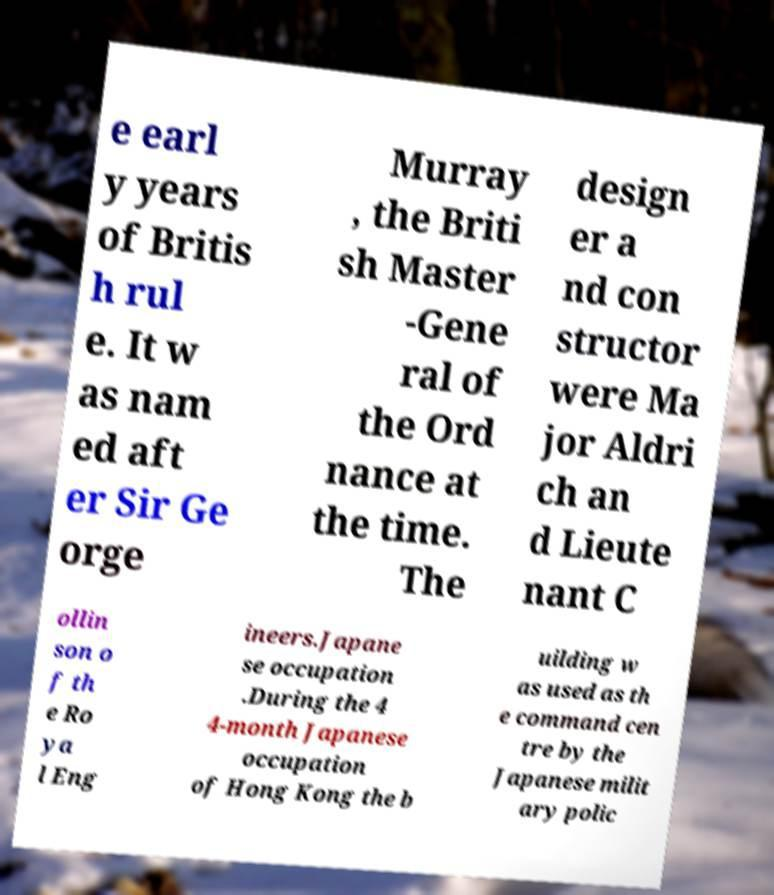What messages or text are displayed in this image? I need them in a readable, typed format. e earl y years of Britis h rul e. It w as nam ed aft er Sir Ge orge Murray , the Briti sh Master -Gene ral of the Ord nance at the time. The design er a nd con structor were Ma jor Aldri ch an d Lieute nant C ollin son o f th e Ro ya l Eng ineers.Japane se occupation .During the 4 4-month Japanese occupation of Hong Kong the b uilding w as used as th e command cen tre by the Japanese milit ary polic 